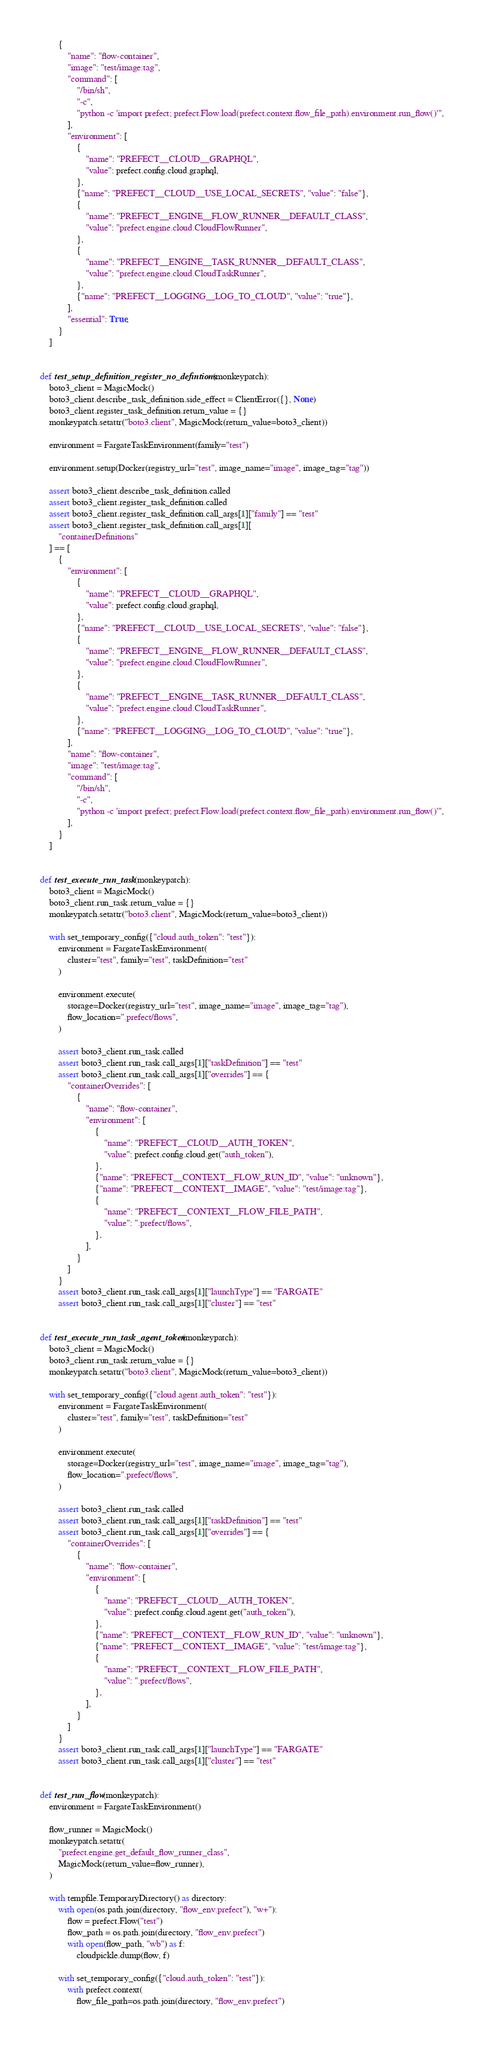Convert code to text. <code><loc_0><loc_0><loc_500><loc_500><_Python_>        {
            "name": "flow-container",
            "image": "test/image:tag",
            "command": [
                "/bin/sh",
                "-c",
                "python -c 'import prefect; prefect.Flow.load(prefect.context.flow_file_path).environment.run_flow()'",
            ],
            "environment": [
                {
                    "name": "PREFECT__CLOUD__GRAPHQL",
                    "value": prefect.config.cloud.graphql,
                },
                {"name": "PREFECT__CLOUD__USE_LOCAL_SECRETS", "value": "false"},
                {
                    "name": "PREFECT__ENGINE__FLOW_RUNNER__DEFAULT_CLASS",
                    "value": "prefect.engine.cloud.CloudFlowRunner",
                },
                {
                    "name": "PREFECT__ENGINE__TASK_RUNNER__DEFAULT_CLASS",
                    "value": "prefect.engine.cloud.CloudTaskRunner",
                },
                {"name": "PREFECT__LOGGING__LOG_TO_CLOUD", "value": "true"},
            ],
            "essential": True,
        }
    ]


def test_setup_definition_register_no_defintions(monkeypatch):
    boto3_client = MagicMock()
    boto3_client.describe_task_definition.side_effect = ClientError({}, None)
    boto3_client.register_task_definition.return_value = {}
    monkeypatch.setattr("boto3.client", MagicMock(return_value=boto3_client))

    environment = FargateTaskEnvironment(family="test")

    environment.setup(Docker(registry_url="test", image_name="image", image_tag="tag"))

    assert boto3_client.describe_task_definition.called
    assert boto3_client.register_task_definition.called
    assert boto3_client.register_task_definition.call_args[1]["family"] == "test"
    assert boto3_client.register_task_definition.call_args[1][
        "containerDefinitions"
    ] == [
        {
            "environment": [
                {
                    "name": "PREFECT__CLOUD__GRAPHQL",
                    "value": prefect.config.cloud.graphql,
                },
                {"name": "PREFECT__CLOUD__USE_LOCAL_SECRETS", "value": "false"},
                {
                    "name": "PREFECT__ENGINE__FLOW_RUNNER__DEFAULT_CLASS",
                    "value": "prefect.engine.cloud.CloudFlowRunner",
                },
                {
                    "name": "PREFECT__ENGINE__TASK_RUNNER__DEFAULT_CLASS",
                    "value": "prefect.engine.cloud.CloudTaskRunner",
                },
                {"name": "PREFECT__LOGGING__LOG_TO_CLOUD", "value": "true"},
            ],
            "name": "flow-container",
            "image": "test/image:tag",
            "command": [
                "/bin/sh",
                "-c",
                "python -c 'import prefect; prefect.Flow.load(prefect.context.flow_file_path).environment.run_flow()'",
            ],
        }
    ]


def test_execute_run_task(monkeypatch):
    boto3_client = MagicMock()
    boto3_client.run_task.return_value = {}
    monkeypatch.setattr("boto3.client", MagicMock(return_value=boto3_client))

    with set_temporary_config({"cloud.auth_token": "test"}):
        environment = FargateTaskEnvironment(
            cluster="test", family="test", taskDefinition="test"
        )

        environment.execute(
            storage=Docker(registry_url="test", image_name="image", image_tag="tag"),
            flow_location=".prefect/flows",
        )

        assert boto3_client.run_task.called
        assert boto3_client.run_task.call_args[1]["taskDefinition"] == "test"
        assert boto3_client.run_task.call_args[1]["overrides"] == {
            "containerOverrides": [
                {
                    "name": "flow-container",
                    "environment": [
                        {
                            "name": "PREFECT__CLOUD__AUTH_TOKEN",
                            "value": prefect.config.cloud.get("auth_token"),
                        },
                        {"name": "PREFECT__CONTEXT__FLOW_RUN_ID", "value": "unknown"},
                        {"name": "PREFECT__CONTEXT__IMAGE", "value": "test/image:tag"},
                        {
                            "name": "PREFECT__CONTEXT__FLOW_FILE_PATH",
                            "value": ".prefect/flows",
                        },
                    ],
                }
            ]
        }
        assert boto3_client.run_task.call_args[1]["launchType"] == "FARGATE"
        assert boto3_client.run_task.call_args[1]["cluster"] == "test"


def test_execute_run_task_agent_token(monkeypatch):
    boto3_client = MagicMock()
    boto3_client.run_task.return_value = {}
    monkeypatch.setattr("boto3.client", MagicMock(return_value=boto3_client))

    with set_temporary_config({"cloud.agent.auth_token": "test"}):
        environment = FargateTaskEnvironment(
            cluster="test", family="test", taskDefinition="test"
        )

        environment.execute(
            storage=Docker(registry_url="test", image_name="image", image_tag="tag"),
            flow_location=".prefect/flows",
        )

        assert boto3_client.run_task.called
        assert boto3_client.run_task.call_args[1]["taskDefinition"] == "test"
        assert boto3_client.run_task.call_args[1]["overrides"] == {
            "containerOverrides": [
                {
                    "name": "flow-container",
                    "environment": [
                        {
                            "name": "PREFECT__CLOUD__AUTH_TOKEN",
                            "value": prefect.config.cloud.agent.get("auth_token"),
                        },
                        {"name": "PREFECT__CONTEXT__FLOW_RUN_ID", "value": "unknown"},
                        {"name": "PREFECT__CONTEXT__IMAGE", "value": "test/image:tag"},
                        {
                            "name": "PREFECT__CONTEXT__FLOW_FILE_PATH",
                            "value": ".prefect/flows",
                        },
                    ],
                }
            ]
        }
        assert boto3_client.run_task.call_args[1]["launchType"] == "FARGATE"
        assert boto3_client.run_task.call_args[1]["cluster"] == "test"


def test_run_flow(monkeypatch):
    environment = FargateTaskEnvironment()

    flow_runner = MagicMock()
    monkeypatch.setattr(
        "prefect.engine.get_default_flow_runner_class",
        MagicMock(return_value=flow_runner),
    )

    with tempfile.TemporaryDirectory() as directory:
        with open(os.path.join(directory, "flow_env.prefect"), "w+"):
            flow = prefect.Flow("test")
            flow_path = os.path.join(directory, "flow_env.prefect")
            with open(flow_path, "wb") as f:
                cloudpickle.dump(flow, f)

        with set_temporary_config({"cloud.auth_token": "test"}):
            with prefect.context(
                flow_file_path=os.path.join(directory, "flow_env.prefect")</code> 